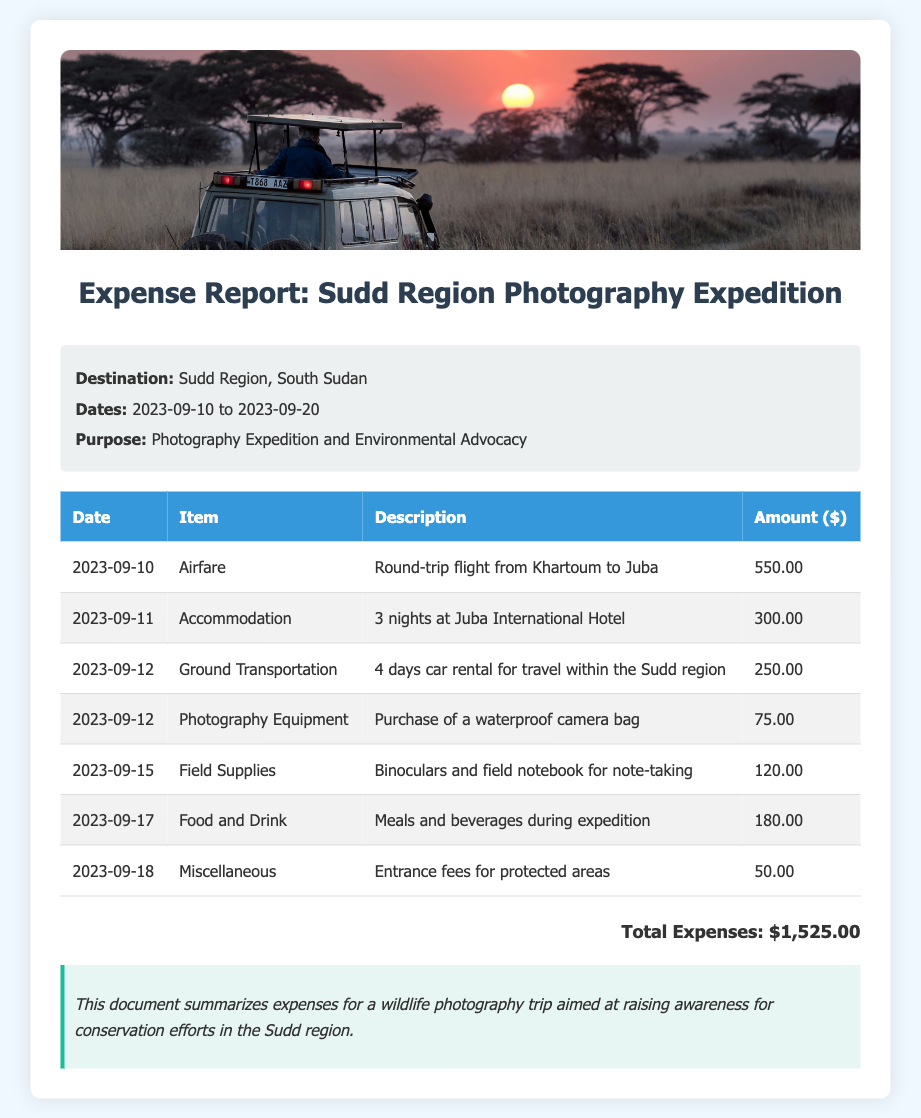What was the total amount spent on airfare? The airfare amount listed in the document is for a round-trip flight from Khartoum to Juba, costing $550.00.
Answer: $550.00 How many days were spent in accommodation? The document indicates that accommodation costs were incurred for 3 nights at Juba International Hotel.
Answer: 3 nights What was the date of the purchase of the waterproof camera bag? The waterproof camera bag was purchased on September 12, 2023, as noted in the expense table.
Answer: 2023-09-12 What is the purpose of the photography expedition? The purpose of the expedition is stated as Photography Expedition and Environmental Advocacy in the trip details section.
Answer: Photography Expedition and Environmental Advocacy What is the total amount spent on food and drink during the trip? The total amount listed for meals and beverages during the expedition is $180.00.
Answer: $180.00 How many items are listed in the expense report? The expense report lists a total of 7 items, as seen in the itemized table.
Answer: 7 items What was the cost for entrance fees for protected areas? The entrance fees for protected areas are stated to be $50.00 in the expense report.
Answer: $50.00 What amount was allocated to field supplies? The document states that $120.00 was spent on binoculars and a field notebook under field supplies.
Answer: $120.00 